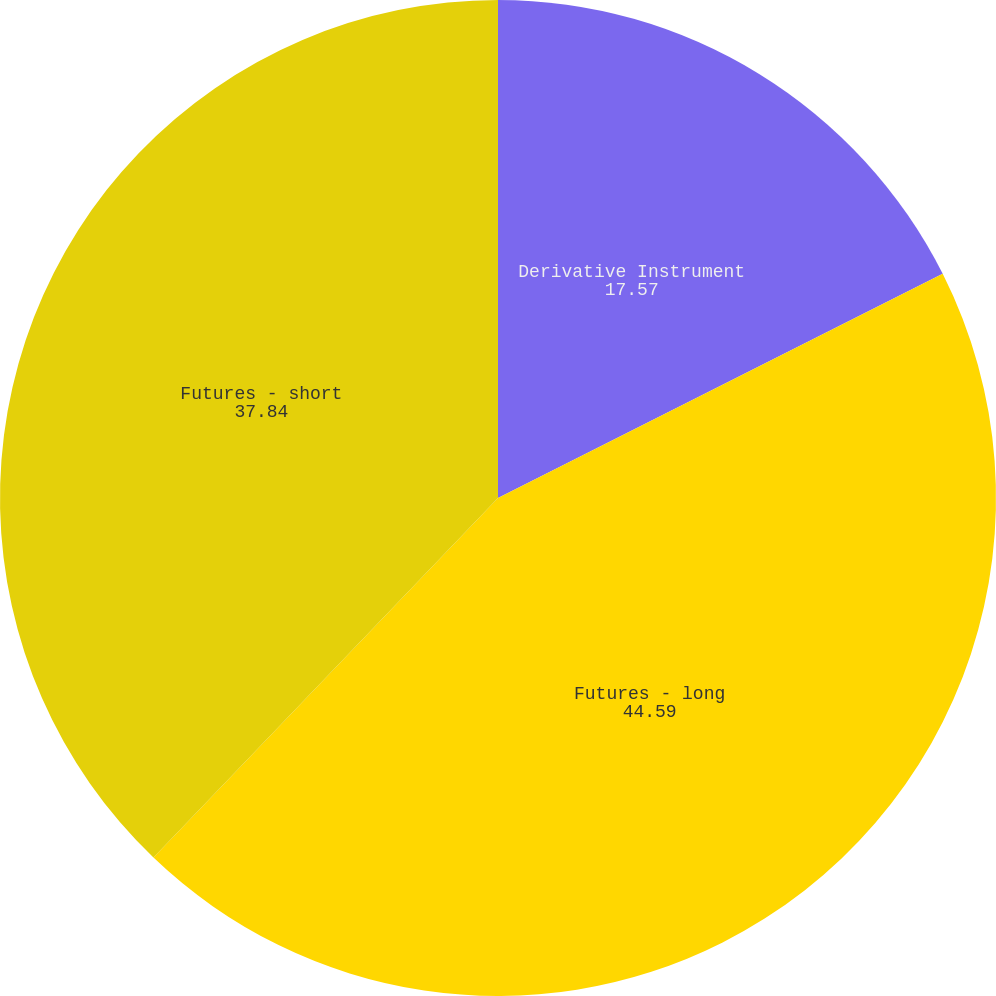<chart> <loc_0><loc_0><loc_500><loc_500><pie_chart><fcel>Derivative Instrument<fcel>Futures - long<fcel>Futures - short<nl><fcel>17.57%<fcel>44.59%<fcel>37.84%<nl></chart> 